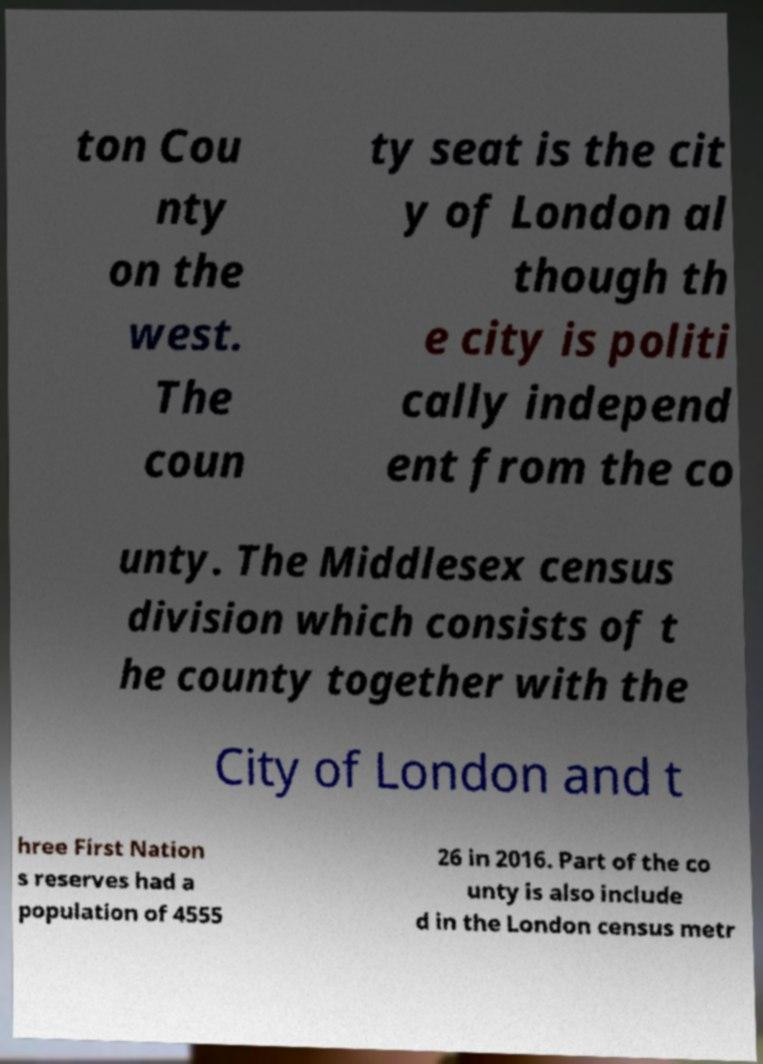What messages or text are displayed in this image? I need them in a readable, typed format. ton Cou nty on the west. The coun ty seat is the cit y of London al though th e city is politi cally independ ent from the co unty. The Middlesex census division which consists of t he county together with the City of London and t hree First Nation s reserves had a population of 4555 26 in 2016. Part of the co unty is also include d in the London census metr 